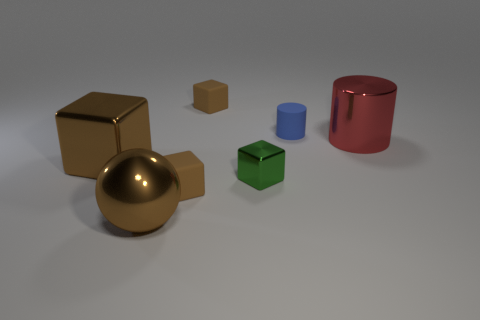What is the tiny green block made of?
Your answer should be very brief. Metal. What shape is the big brown object behind the small green metal block?
Your answer should be very brief. Cube. Is there a metal thing that has the same size as the blue cylinder?
Ensure brevity in your answer.  Yes. Is the cube that is on the left side of the brown metal ball made of the same material as the brown ball?
Your answer should be compact. Yes. Is the number of cylinders on the left side of the big brown block the same as the number of blue rubber cylinders behind the large shiny cylinder?
Ensure brevity in your answer.  No. The small object that is behind the red metallic cylinder and to the left of the tiny blue rubber object has what shape?
Your answer should be very brief. Cube. There is a small blue cylinder; what number of small matte cubes are behind it?
Make the answer very short. 1. What number of other things are the same shape as the small green thing?
Provide a succinct answer. 3. Are there fewer tiny cyan metal spheres than rubber cylinders?
Provide a succinct answer. Yes. There is a brown block that is in front of the tiny blue rubber thing and on the right side of the large brown shiny sphere; what size is it?
Your answer should be compact. Small. 